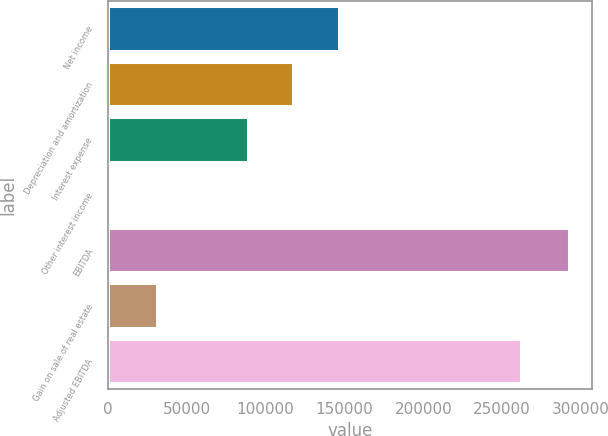<chart> <loc_0><loc_0><loc_500><loc_500><bar_chart><fcel>Net income<fcel>Depreciation and amortization<fcel>Interest expense<fcel>Other interest income<fcel>EBITDA<fcel>Gain on sale of real estate<fcel>Adjusted EBITDA<nl><fcel>146616<fcel>117591<fcel>88566<fcel>2216<fcel>292465<fcel>31240.9<fcel>261717<nl></chart> 